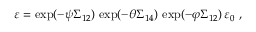Convert formula to latex. <formula><loc_0><loc_0><loc_500><loc_500>\varepsilon = \exp ( - \psi \Sigma _ { 1 2 } ) \, \exp ( - \theta \Sigma _ { 1 4 } ) \, \exp ( - \varphi \Sigma _ { 1 2 } ) \, \varepsilon _ { 0 } ,</formula> 